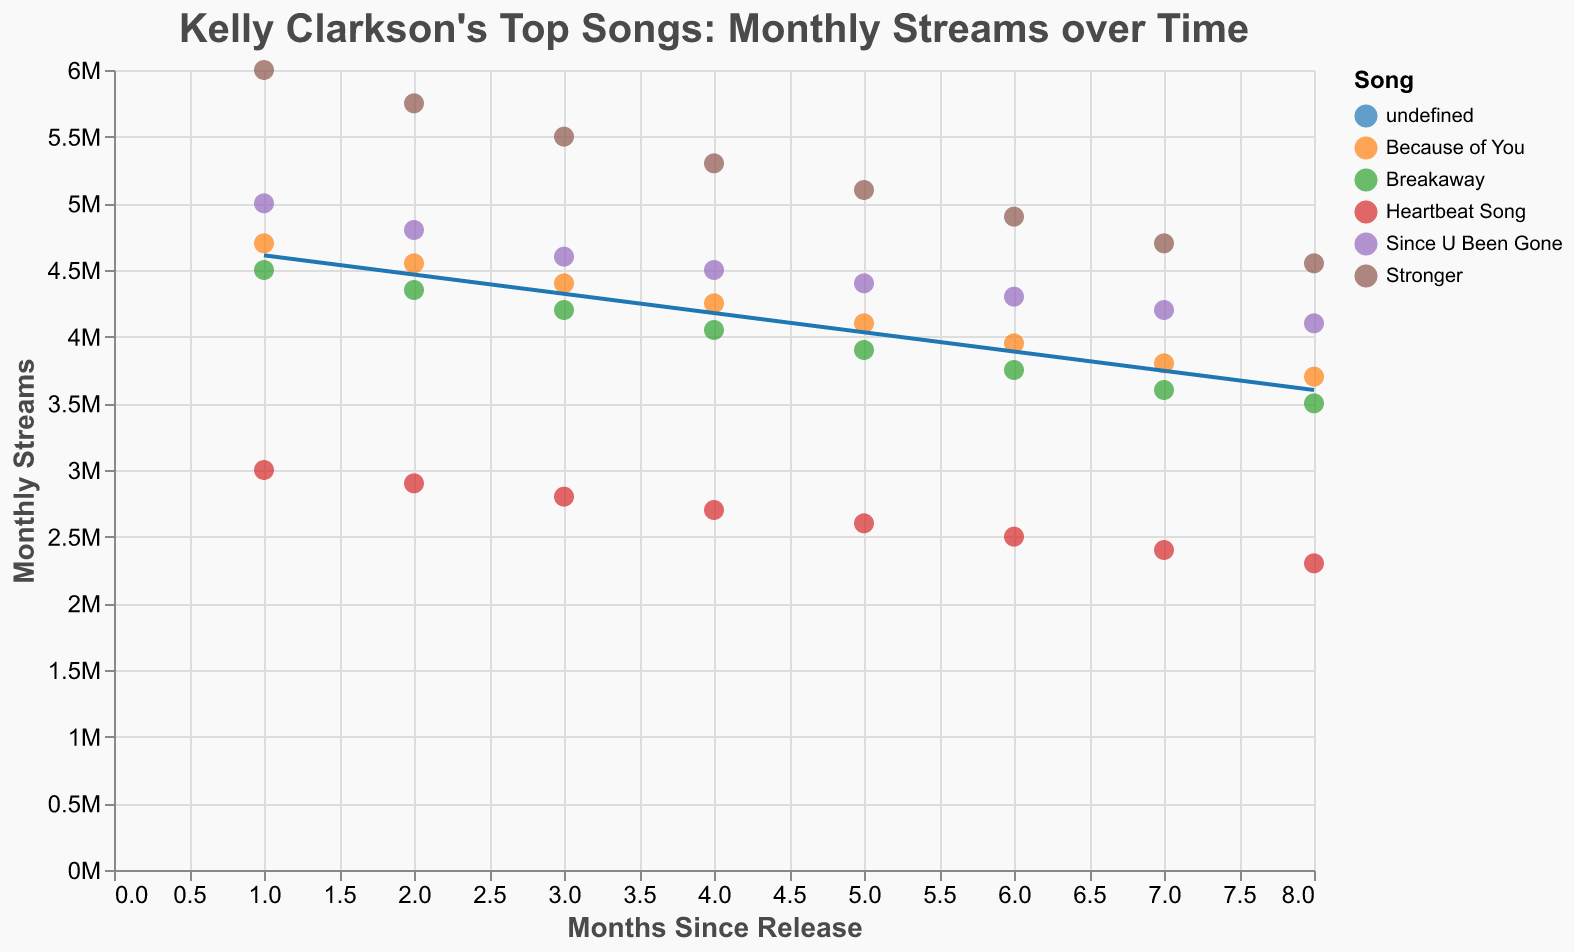What is the title of the figure? The title of the figure is visually displayed at the top and it's typically used to describe the contents.
Answer: Kelly Clarkson's Top Songs: Monthly Streams over Time How many months of streaming data are represented for each song? The x-axis represents the number of months since the release, and each song has data points stretching from month 1 to month 8.
Answer: 8 months Which song had the highest monthly streams in the first month since release? By looking at the y-axis (Monthly Streams) for the month labeled as 1 on the x-axis, "Stronger" had the highest monthly streams.
Answer: Stronger What trend can be observed for the song "Since U Been Gone"? Observing the trend line for "Since U Been Gone," the monthly streams consistently decrease over the 8 months since release.
Answer: Decreasing trend Compare the monthly streams of "Breakaway" and "Because of You" at month 5 since release. Which one had higher streams? At month 5 (x-axis), compare the y-values of the points for "Breakaway" and "Because of You". "Because of You" had higher streams than "Breakaway."
Answer: Because of You What is the average monthly streams of "Heartbeat Song" over the 8 months? Calculate the averages of the y-values for "Heartbeat Song": (3000000 + 2900000 + 2800000 + 2700000 + 2600000 + 2500000 + 2400000 + 2300000) / 8.
Answer: 2650000 Do the songs' monthly streams generally increase or decrease over time? By observing the trend lines for all the songs, they all show a general decrease in monthly streams over the 8-month period.
Answer: Decrease Which song has the most consistent monthly streams over the 8 months? The consistency can be judged by the flatness of the trend line. "Because of You" has a relatively flatter trend line compared to others.
Answer: Because of You What is the difference in monthly streams between "Stronger" and "Heartbeat Song" in the first month? Subtract the y-value of "Heartbeat Song" from that of "Stronger" at month 1: 6000000 - 3000000.
Answer: 3000000 Based on the trend lines, which song is likely to have the least monthly streams if the observation continues beyond 8 months? The song "Heartbeat Song," has the steepest declining trend.
Answer: Heartbeat Song 